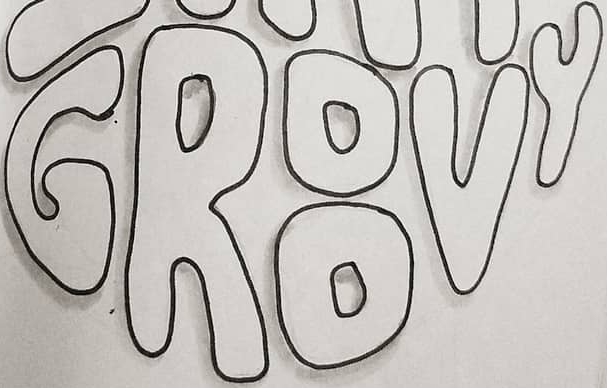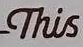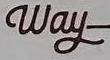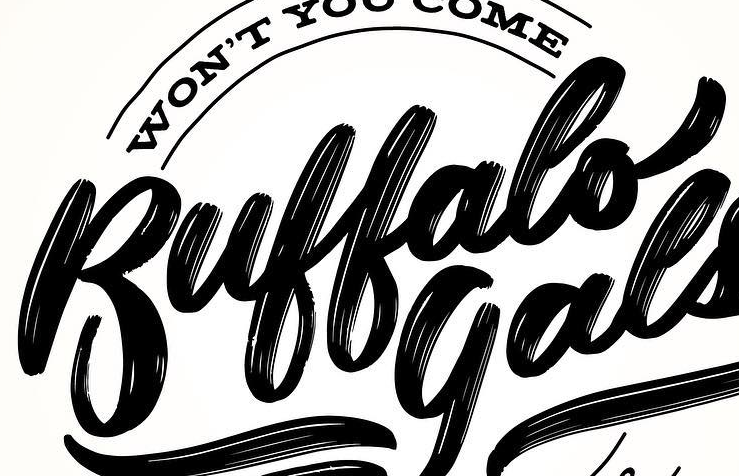What text appears in these images from left to right, separated by a semicolon? GROOVY; This; Way; Buffalo 